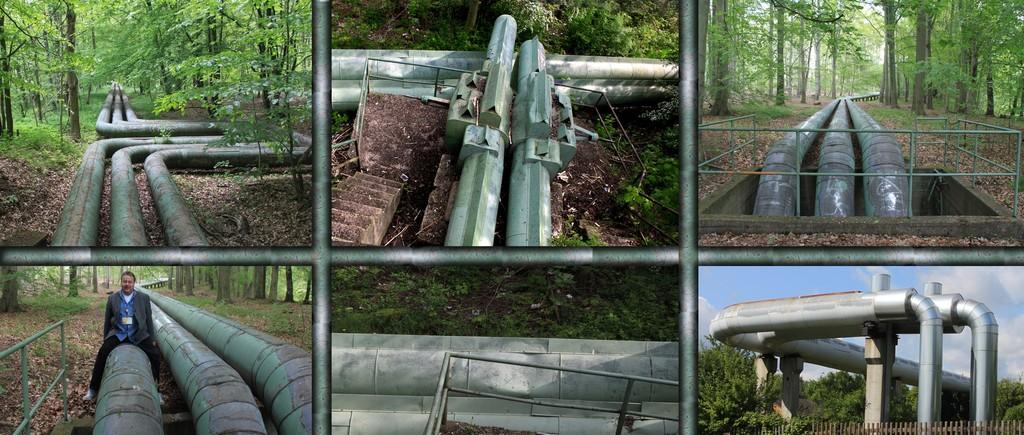Who or what is present in the image? There is a person in the image. What else can be seen in the image besides the person? There are pipes and trees in the image. How many times does the beginner sneeze in the image? There is no indication of anyone sneezing or being a beginner in the image. 